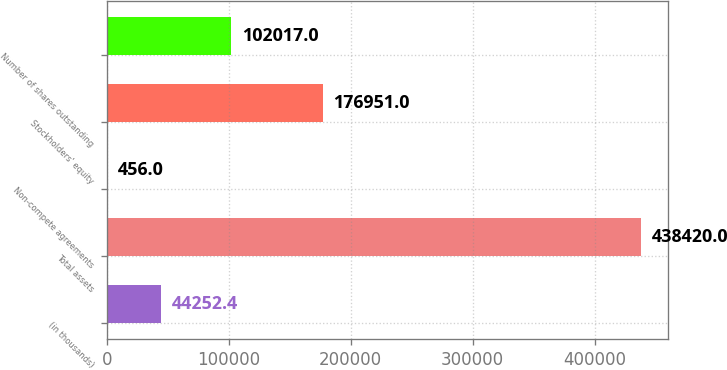<chart> <loc_0><loc_0><loc_500><loc_500><bar_chart><fcel>(in thousands)<fcel>Total assets<fcel>Non-compete agreements<fcel>Stockholders' equity<fcel>Number of shares outstanding<nl><fcel>44252.4<fcel>438420<fcel>456<fcel>176951<fcel>102017<nl></chart> 